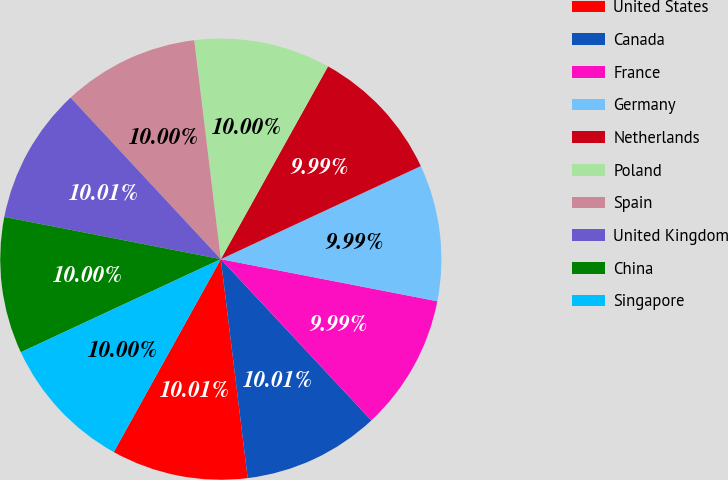Convert chart to OTSL. <chart><loc_0><loc_0><loc_500><loc_500><pie_chart><fcel>United States<fcel>Canada<fcel>France<fcel>Germany<fcel>Netherlands<fcel>Poland<fcel>Spain<fcel>United Kingdom<fcel>China<fcel>Singapore<nl><fcel>10.01%<fcel>10.01%<fcel>9.99%<fcel>9.99%<fcel>9.99%<fcel>10.0%<fcel>10.0%<fcel>10.01%<fcel>10.0%<fcel>10.0%<nl></chart> 